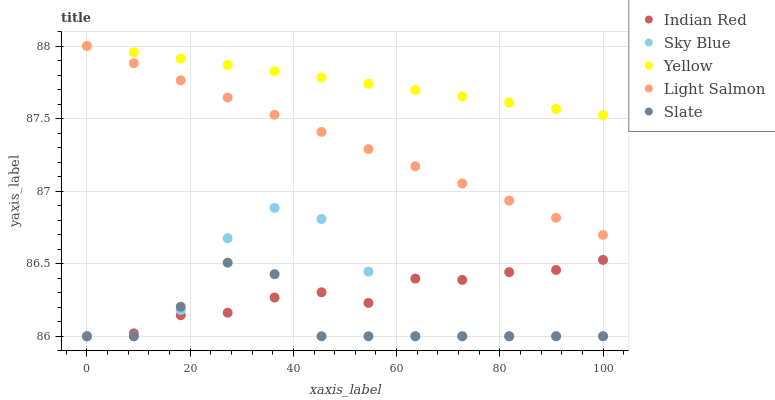Does Slate have the minimum area under the curve?
Answer yes or no. Yes. Does Yellow have the maximum area under the curve?
Answer yes or no. Yes. Does Light Salmon have the minimum area under the curve?
Answer yes or no. No. Does Light Salmon have the maximum area under the curve?
Answer yes or no. No. Is Yellow the smoothest?
Answer yes or no. Yes. Is Sky Blue the roughest?
Answer yes or no. Yes. Is Light Salmon the smoothest?
Answer yes or no. No. Is Light Salmon the roughest?
Answer yes or no. No. Does Sky Blue have the lowest value?
Answer yes or no. Yes. Does Light Salmon have the lowest value?
Answer yes or no. No. Does Yellow have the highest value?
Answer yes or no. Yes. Does Slate have the highest value?
Answer yes or no. No. Is Indian Red less than Yellow?
Answer yes or no. Yes. Is Light Salmon greater than Sky Blue?
Answer yes or no. Yes. Does Sky Blue intersect Slate?
Answer yes or no. Yes. Is Sky Blue less than Slate?
Answer yes or no. No. Is Sky Blue greater than Slate?
Answer yes or no. No. Does Indian Red intersect Yellow?
Answer yes or no. No. 